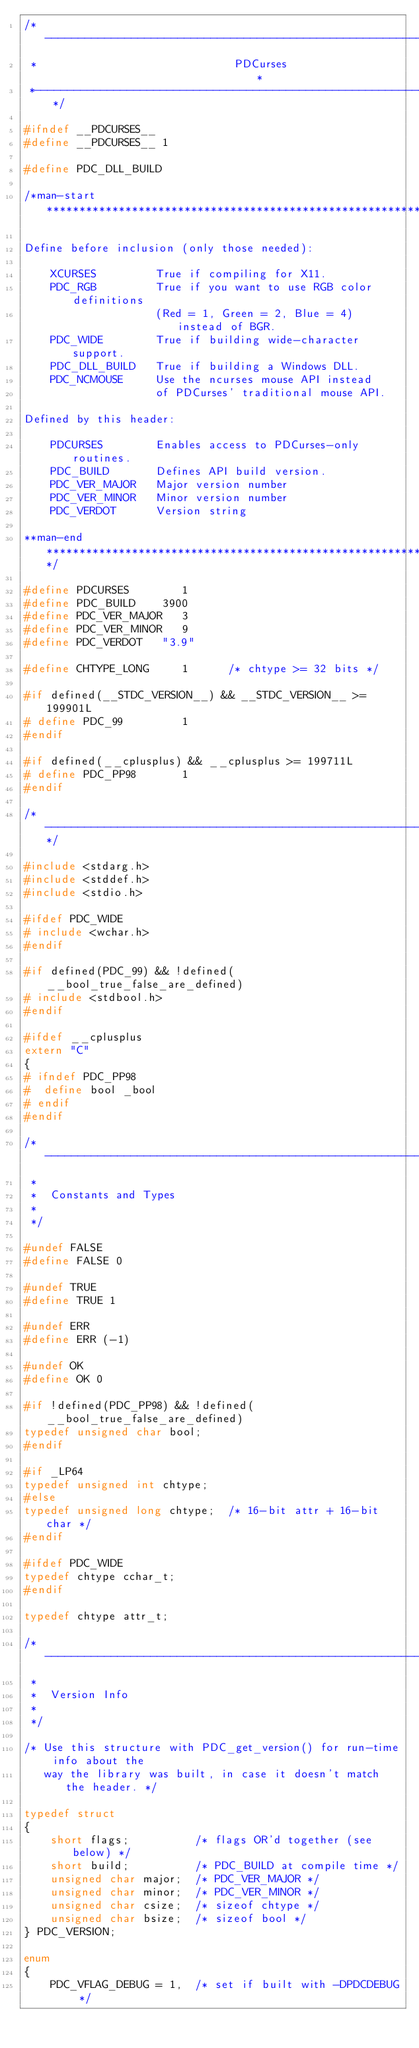Convert code to text. <code><loc_0><loc_0><loc_500><loc_500><_C_>/*----------------------------------------------------------------------*
 *                              PDCurses                                *
 *----------------------------------------------------------------------*/

#ifndef __PDCURSES__
#define __PDCURSES__ 1

#define PDC_DLL_BUILD

/*man-start**************************************************************

Define before inclusion (only those needed):

    XCURSES         True if compiling for X11.
    PDC_RGB         True if you want to use RGB color definitions
                    (Red = 1, Green = 2, Blue = 4) instead of BGR.
    PDC_WIDE        True if building wide-character support.
    PDC_DLL_BUILD   True if building a Windows DLL.
    PDC_NCMOUSE     Use the ncurses mouse API instead
                    of PDCurses' traditional mouse API.

Defined by this header:

    PDCURSES        Enables access to PDCurses-only routines.
    PDC_BUILD       Defines API build version.
    PDC_VER_MAJOR   Major version number
    PDC_VER_MINOR   Minor version number
    PDC_VERDOT      Version string

**man-end****************************************************************/

#define PDCURSES        1
#define PDC_BUILD    3900
#define PDC_VER_MAJOR   3
#define PDC_VER_MINOR   9
#define PDC_VERDOT   "3.9"

#define CHTYPE_LONG     1      /* chtype >= 32 bits */

#if defined(__STDC_VERSION__) && __STDC_VERSION__ >= 199901L
# define PDC_99         1
#endif

#if defined(__cplusplus) && __cplusplus >= 199711L
# define PDC_PP98       1
#endif

/*----------------------------------------------------------------------*/

#include <stdarg.h>
#include <stddef.h>
#include <stdio.h>

#ifdef PDC_WIDE
# include <wchar.h>
#endif

#if defined(PDC_99) && !defined(__bool_true_false_are_defined)
# include <stdbool.h>
#endif

#ifdef __cplusplus
extern "C"
{
# ifndef PDC_PP98
#  define bool _bool
# endif
#endif

/*----------------------------------------------------------------------
 *
 *  Constants and Types
 *
 */

#undef FALSE
#define FALSE 0

#undef TRUE
#define TRUE 1

#undef ERR
#define ERR (-1)

#undef OK
#define OK 0

#if !defined(PDC_PP98) && !defined(__bool_true_false_are_defined)
typedef unsigned char bool;
#endif

#if _LP64
typedef unsigned int chtype;
#else
typedef unsigned long chtype;  /* 16-bit attr + 16-bit char */
#endif

#ifdef PDC_WIDE
typedef chtype cchar_t;
#endif

typedef chtype attr_t;

/*----------------------------------------------------------------------
 *
 *  Version Info
 *
 */

/* Use this structure with PDC_get_version() for run-time info about the
   way the library was built, in case it doesn't match the header. */

typedef struct
{
    short flags;          /* flags OR'd together (see below) */
    short build;          /* PDC_BUILD at compile time */
    unsigned char major;  /* PDC_VER_MAJOR */
    unsigned char minor;  /* PDC_VER_MINOR */
    unsigned char csize;  /* sizeof chtype */
    unsigned char bsize;  /* sizeof bool */
} PDC_VERSION;

enum
{
    PDC_VFLAG_DEBUG = 1,  /* set if built with -DPDCDEBUG */</code> 